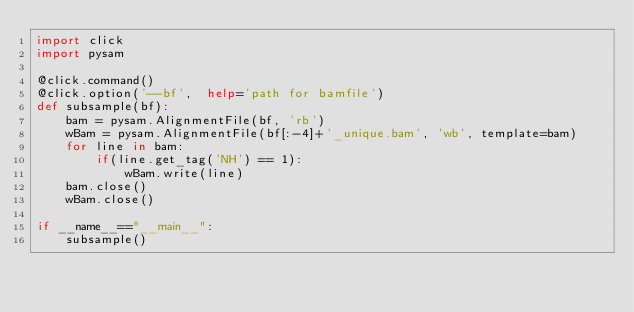Convert code to text. <code><loc_0><loc_0><loc_500><loc_500><_Python_>import click
import pysam

@click.command()
@click.option('--bf',  help='path for bamfile')
def subsample(bf):
    bam = pysam.AlignmentFile(bf, 'rb')
    wBam = pysam.AlignmentFile(bf[:-4]+'_unique.bam', 'wb', template=bam)
    for line in bam:
        if(line.get_tag('NH') == 1):
            wBam.write(line)
    bam.close()
    wBam.close()

if __name__=="__main__":
    subsample()

</code> 